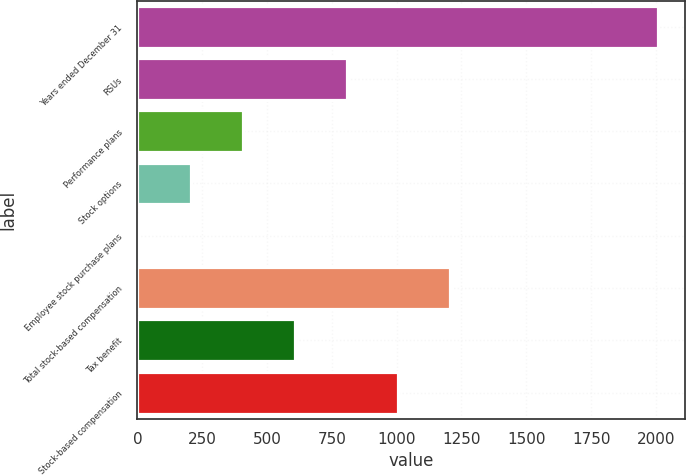<chart> <loc_0><loc_0><loc_500><loc_500><bar_chart><fcel>Years ended December 31<fcel>RSUs<fcel>Performance plans<fcel>Stock options<fcel>Employee stock purchase plans<fcel>Total stock-based compensation<fcel>Tax benefit<fcel>Stock-based compensation<nl><fcel>2010<fcel>806.4<fcel>405.2<fcel>204.6<fcel>4<fcel>1207.6<fcel>605.8<fcel>1007<nl></chart> 